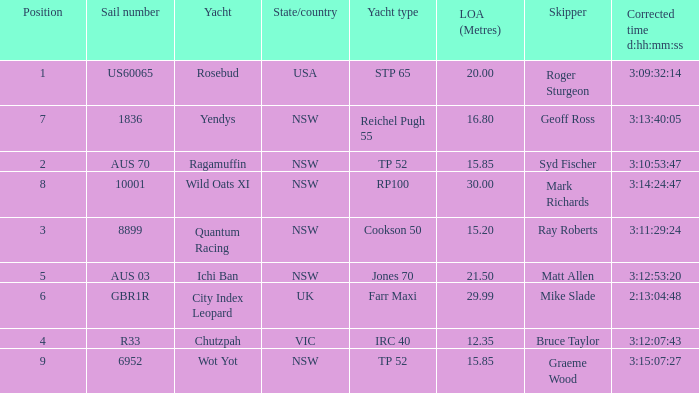Who were all of the skippers with a corrected time of 3:15:07:27? Graeme Wood. 